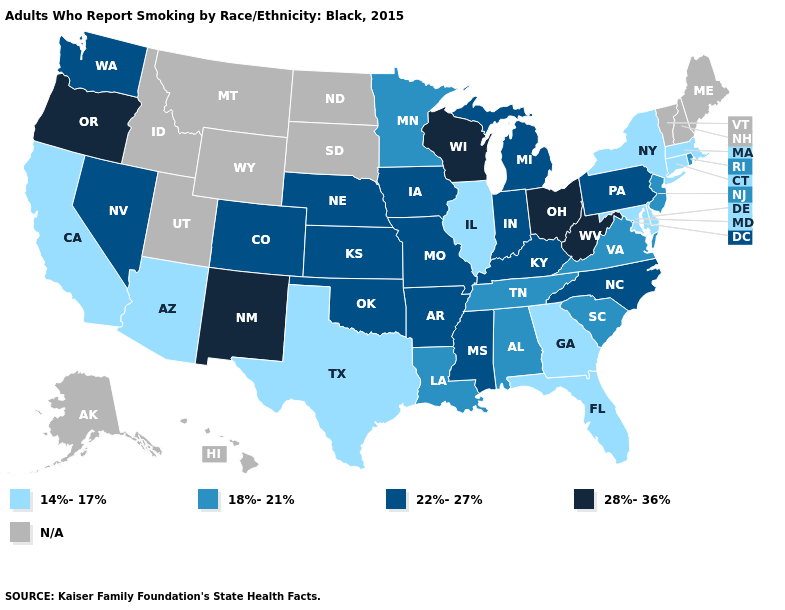What is the value of Pennsylvania?
Short answer required. 22%-27%. What is the highest value in the USA?
Concise answer only. 28%-36%. Is the legend a continuous bar?
Keep it brief. No. What is the value of Texas?
Short answer required. 14%-17%. Name the states that have a value in the range N/A?
Keep it brief. Alaska, Hawaii, Idaho, Maine, Montana, New Hampshire, North Dakota, South Dakota, Utah, Vermont, Wyoming. Is the legend a continuous bar?
Short answer required. No. Name the states that have a value in the range 14%-17%?
Concise answer only. Arizona, California, Connecticut, Delaware, Florida, Georgia, Illinois, Maryland, Massachusetts, New York, Texas. What is the lowest value in the USA?
Answer briefly. 14%-17%. What is the value of Idaho?
Answer briefly. N/A. Does California have the lowest value in the USA?
Short answer required. Yes. What is the value of Wisconsin?
Answer briefly. 28%-36%. Name the states that have a value in the range 18%-21%?
Be succinct. Alabama, Louisiana, Minnesota, New Jersey, Rhode Island, South Carolina, Tennessee, Virginia. What is the lowest value in the USA?
Short answer required. 14%-17%. 